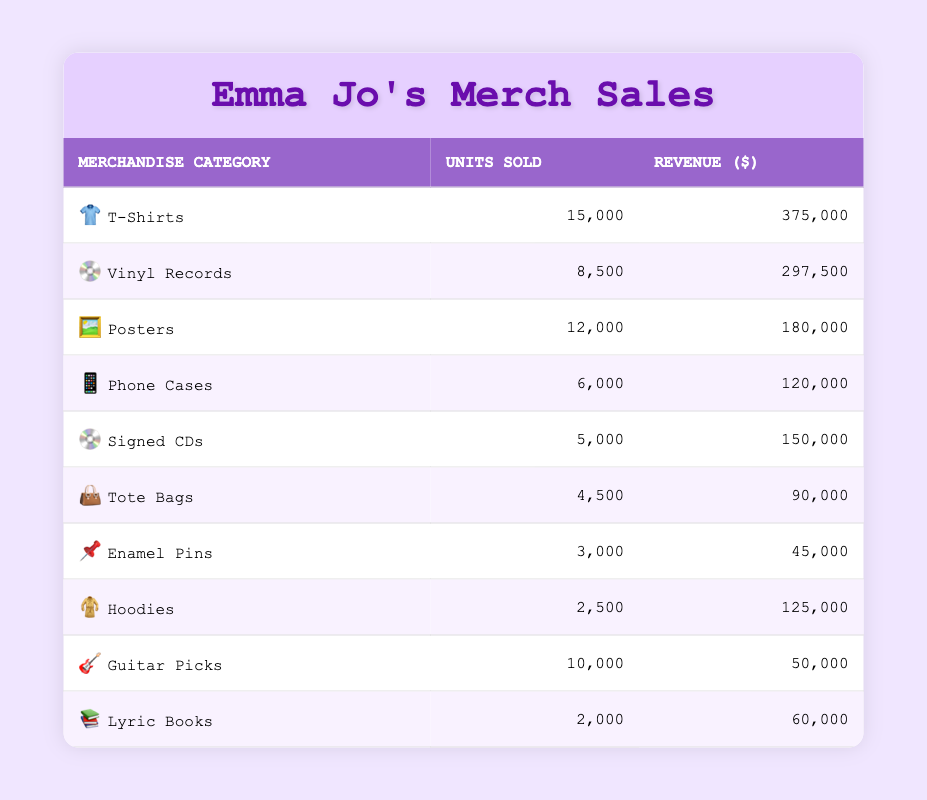What is the merchandise category with the highest revenue? To find the highest revenue, we compare the revenue of each category. The T-Shirts category has the highest revenue at $375,000.
Answer: T-Shirts How many units of Phone Cases were sold? Directly from the table, we can see that the number of units sold for Phone Cases is 6,000.
Answer: 6,000 What is the total revenue generated from Tote Bags and Lyric Books combined? First, we find the revenue for Tote Bags, which is $90,000, and for Lyric Books, which is $60,000. Then we add them together: 90,000 + 60,000 = 150,000.
Answer: 150,000 Did more units of Signed CDs sell than Enamel Pins? From the table, Signed CDs sold 5,000 units and Enamel Pins sold 3,000 units. Since 5,000 is greater than 3,000, the statement is true.
Answer: Yes What is the average number of units sold across all merchandise categories? We add all units sold: 15,000 + 8,500 + 12,000 + 6,000 + 5,000 + 4,500 + 3,000 + 2,500 + 10,000 + 2,000 = 68,500. There are 10 categories, so we divide: 68,500 / 10 = 6,850.
Answer: 6,850 What is the difference in revenue between Vinyl Records and Hoodies? Vinyl Records generated $297,500 in revenue, while Hoodies generated $125,000. The difference is 297,500 - 125,000 = 172,500.
Answer: 172,500 How many more units of T-Shirts were sold than Posters? T-Shirts sold 15,000 units and Posters sold 12,000 units. The difference is 15,000 - 12,000 = 3,000.
Answer: 3,000 Is the total revenue from all categories over a million dollars? We calculate the total revenue: 375,000 + 297,500 + 180,000 + 120,000 + 150,000 + 90,000 + 45,000 + 125,000 + 50,000 + 60,000 = 1,517,500. Since this is over a million, the statement is true.
Answer: Yes What merchandise category sold more than 10,000 units? Looking at the table, T-Shirts (15,000) and Guitar Picks (10,000) are the categories that sold more than 10,000 units.
Answer: T-Shirts, Guitar Picks 